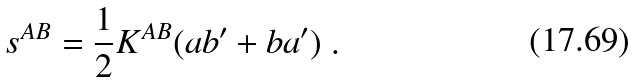<formula> <loc_0><loc_0><loc_500><loc_500>s ^ { A B } = \frac { 1 } { 2 } K ^ { A B } ( a b ^ { \prime } + b a ^ { \prime } ) \ .</formula> 